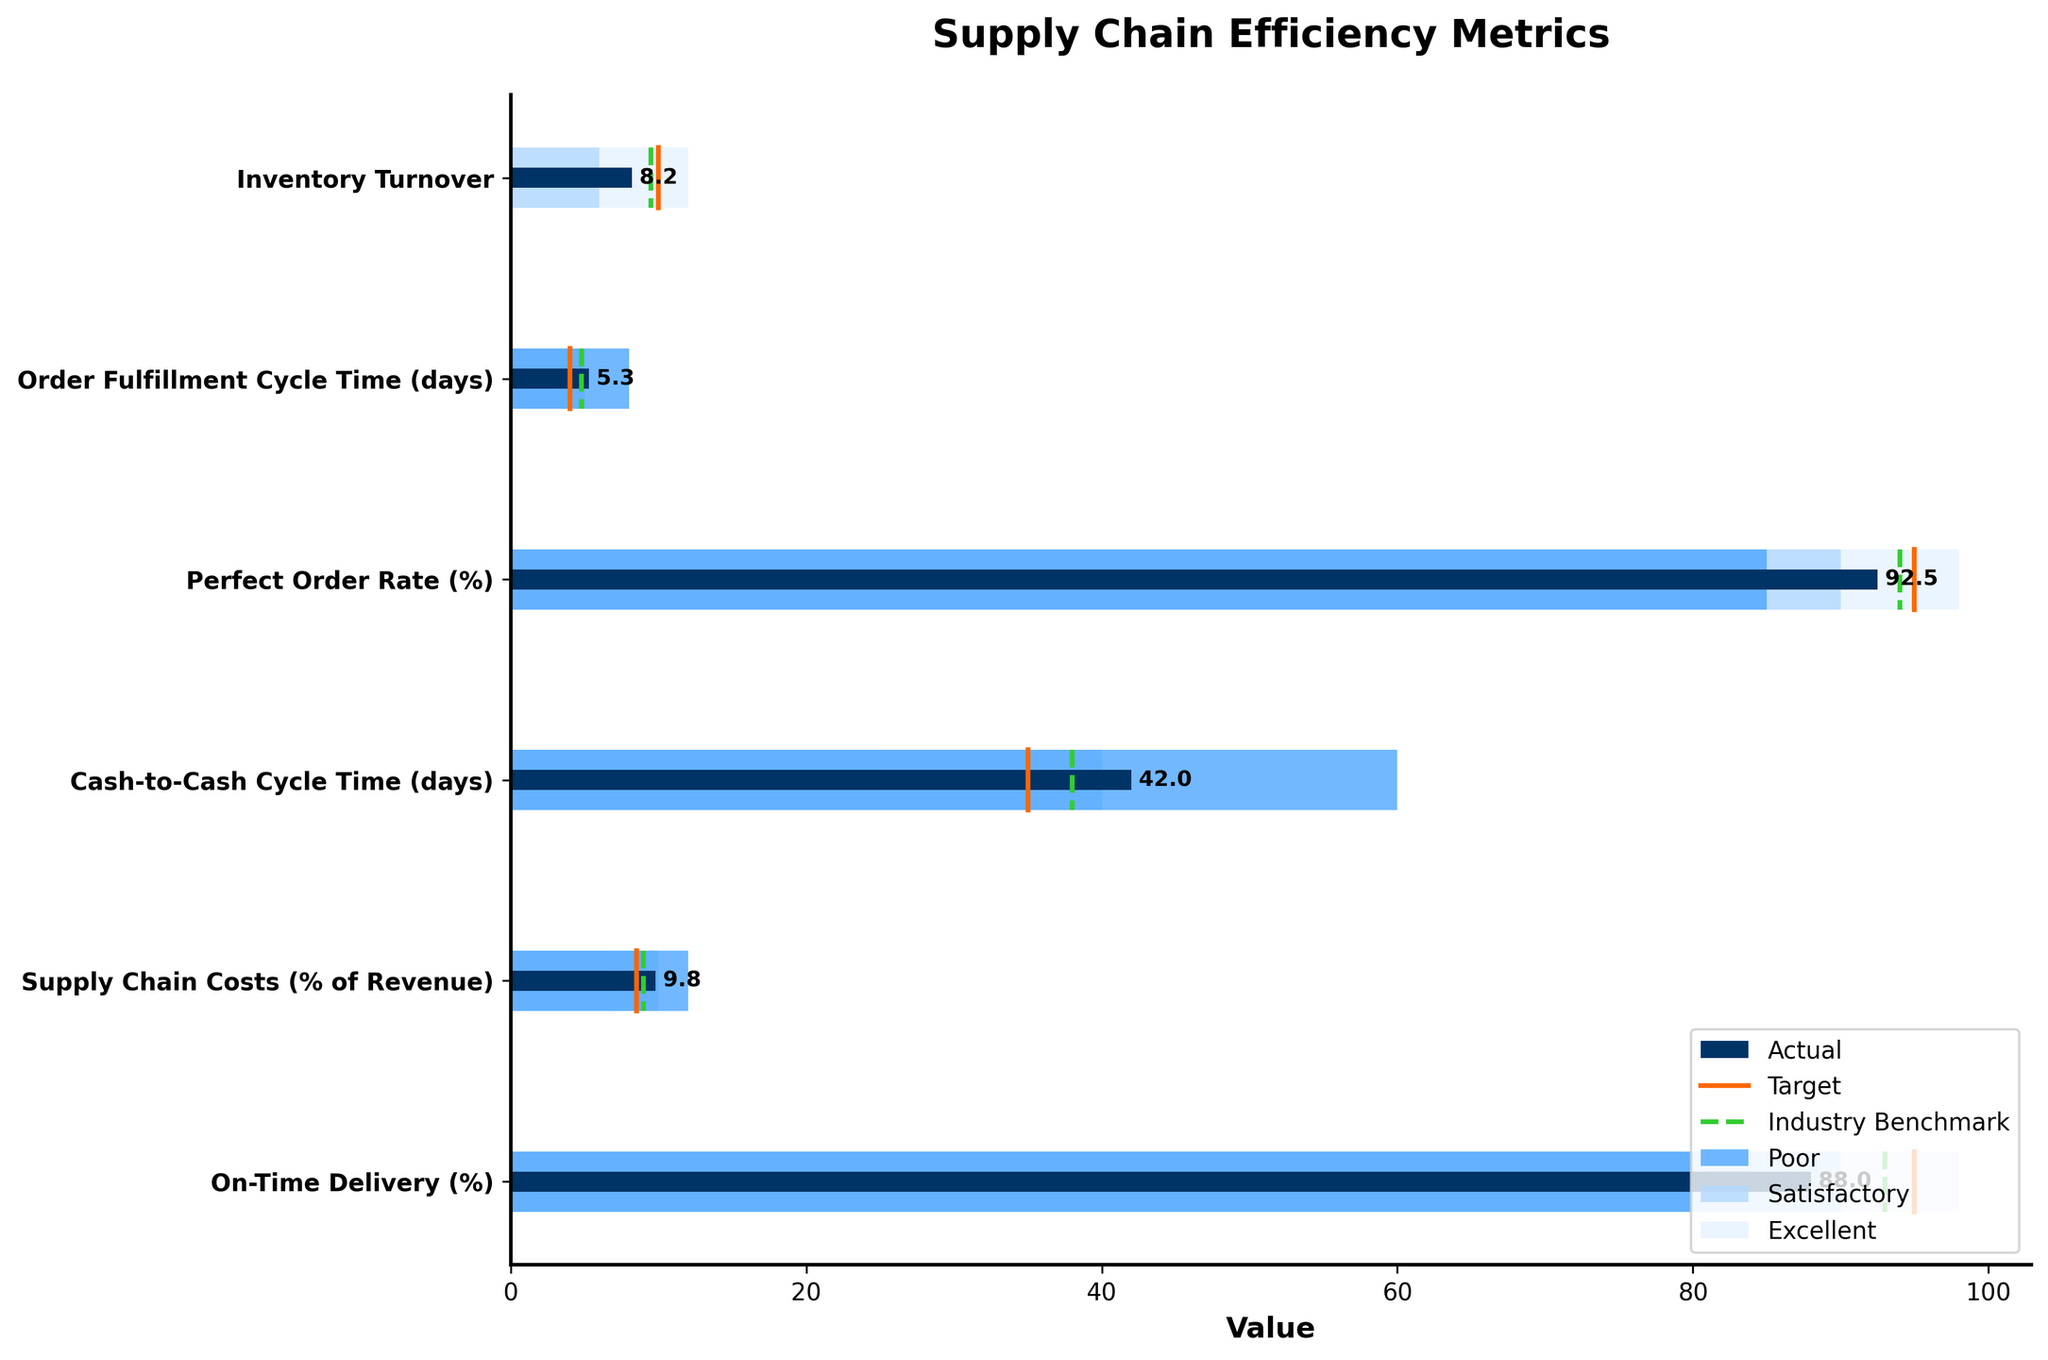What metric shows the largest gap between Actual and Target values? The largest gap can be identified by calculating the absolute difference between Actual and Target for each metric. The gaps are: 1.8 for Inventory Turnover, 1.3 for Order Fulfillment Cycle Time, 2.5 for Perfect Order Rate, 7 for Cash-to-Cash Cycle Time, 1.3 for Supply Chain Costs, and 7 for On-Time Delivery. The largest gap is 7 days for Cash-to-Cash Cycle Time and 7% for On-Time Delivery.
Answer: Cash-to-Cash Cycle Time and On-Time Delivery Which metric performs better than the Industry Benchmark but worse than the Target? To find this, compare the Actual values with the Industry Benchmark and Target for each metric. The metrics where Actual is better than Benchmark but worse than Target are Perfect Order Rate (92.5% vs. 94% benchmark, 95% target) and Supply Chain Costs (9.8% vs. 9% benchmark, 8.5% target).
Answer: Perfect Order Rate and Supply Chain Costs What is the title of the figure? The title is usually located at the top-center of the figure.
Answer: Supply Chain Efficiency Metrics Which metric has the smallest range between Poor and Excellent performance? The ranges between Poor and Excellent can be calculated as the difference between the Excellent and Poor values for each metric. The ranges are: Inventory Turnover (12 - 0 = 12), Order Fulfillment Cycle Time (8 - 3 = 5), Perfect Order Rate (98 - 85 = 13), Cash-to-Cash Cycle Time (60 - 25 = 35), Supply Chain Costs (12 - 7 = 5), and On-Time Delivery (98 - 80 = 18). The smallest ranges are Order Fulfillment Cycle Time and Supply Chain Costs, both with 5 units.
Answer: Order Fulfillment Cycle Time and Supply Chain Costs How many different colors are used in the background bars to indicate performance levels? The background bars use three different colors to represent Poor, Satisfactory, and Excellent performance levels.
Answer: Three Which metric has the closest Actual value to the Industry Benchmark? The closeness can be determined by calculating the absolute difference between the Actual values and Industry Benchmark for each metric. The differences are: 0.7 for Inventory Turnover, 0.5 for Order Fulfillment Cycle Time, 1.5 for Perfect Order Rate, 4 for Cash-to-Cash Cycle Time, 0.8 for Supply Chain Costs, and 5 for On-Time Delivery. The closest one is Order Fulfillment Cycle Time.
Answer: Order Fulfillment Cycle Time What is the target for On-Time Delivery? The target for On-Time Delivery is denoted by the vertical line colored in the specific section for it.
Answer: 95% Which metric shows excellent performance according to the background color? A metric shows excellent performance if its Actual value falls within the range specified by the Excellent background color. For all metrics, compare Actual values to the Excellent range. All Actual values fail to meet the Excellent performance mark based on the given data ranges.
Answer: None 